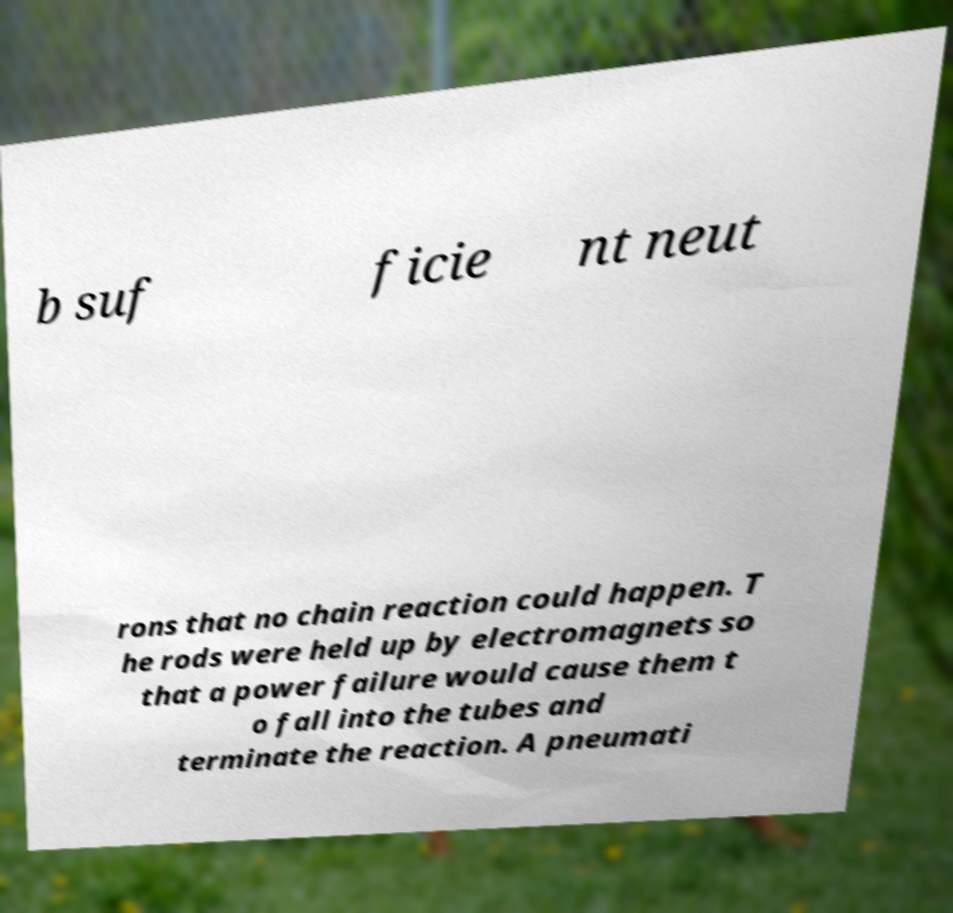Can you read and provide the text displayed in the image?This photo seems to have some interesting text. Can you extract and type it out for me? b suf ficie nt neut rons that no chain reaction could happen. T he rods were held up by electromagnets so that a power failure would cause them t o fall into the tubes and terminate the reaction. A pneumati 